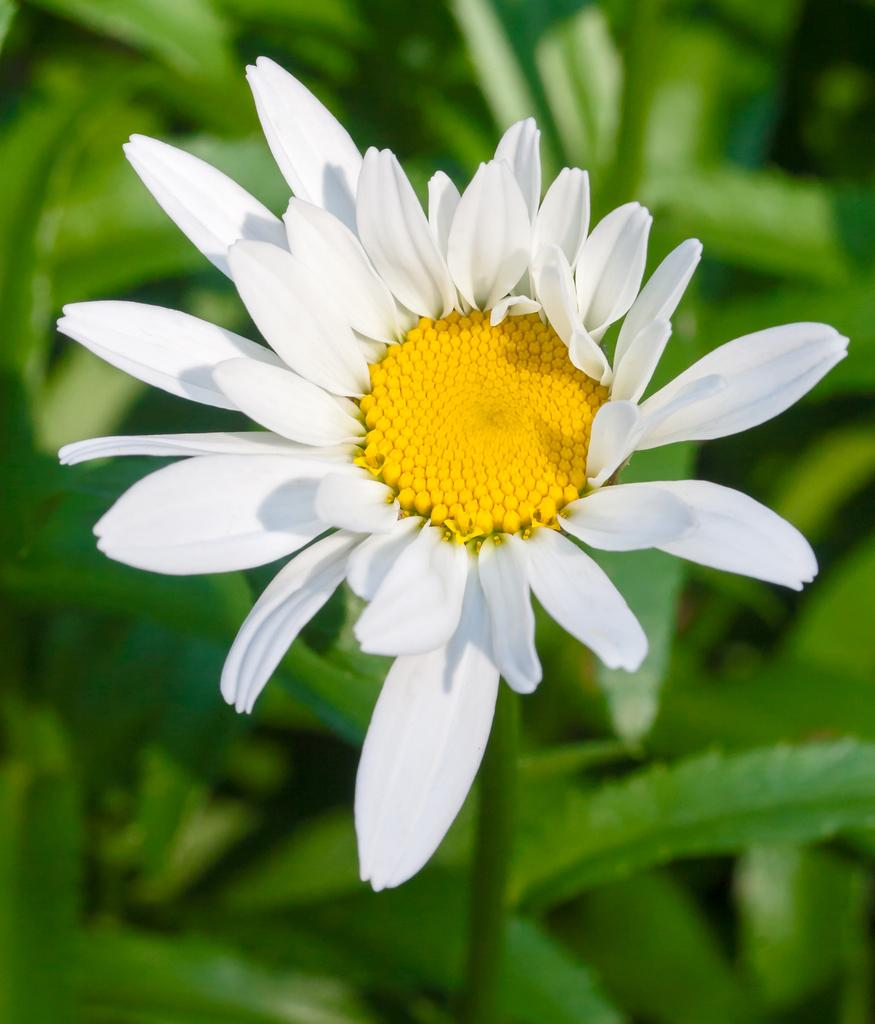What type of plant is visible in the image? There is a plant with a flower in the image. What other features can be seen on the plant? There are many leaves visible at the bottom of the plant in the image. How many apples are hanging from the branches of the plant in the image? There are no apples present in the image; it features a plant with a flower and leaves. Is there any snow visible on the plant or around it in the image? There is no snow present in the image; it appears to be a close-up of a plant with a flower and leaves. 